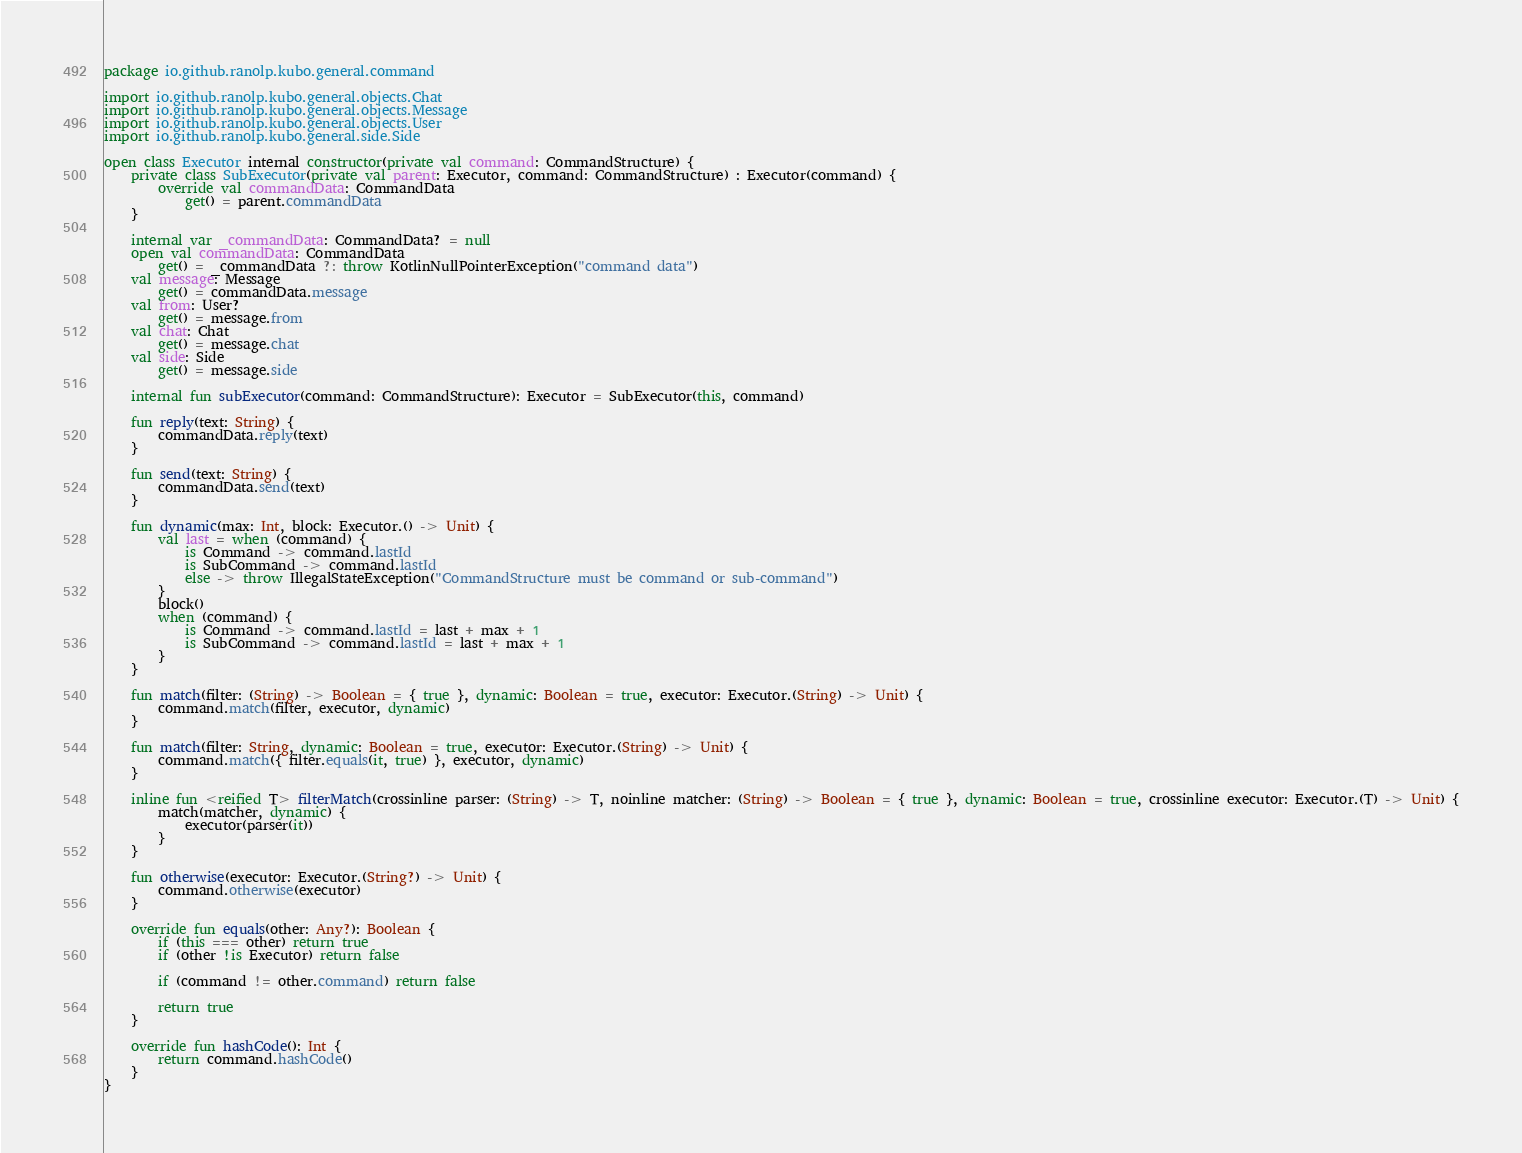Convert code to text. <code><loc_0><loc_0><loc_500><loc_500><_Kotlin_>package io.github.ranolp.kubo.general.command

import io.github.ranolp.kubo.general.objects.Chat
import io.github.ranolp.kubo.general.objects.Message
import io.github.ranolp.kubo.general.objects.User
import io.github.ranolp.kubo.general.side.Side

open class Executor internal constructor(private val command: CommandStructure) {
    private class SubExecutor(private val parent: Executor, command: CommandStructure) : Executor(command) {
        override val commandData: CommandData
            get() = parent.commandData
    }

    internal var _commandData: CommandData? = null
    open val commandData: CommandData
        get() = _commandData ?: throw KotlinNullPointerException("command data")
    val message: Message
        get() = commandData.message
    val from: User?
        get() = message.from
    val chat: Chat
        get() = message.chat
    val side: Side
        get() = message.side

    internal fun subExecutor(command: CommandStructure): Executor = SubExecutor(this, command)

    fun reply(text: String) {
        commandData.reply(text)
    }

    fun send(text: String) {
        commandData.send(text)
    }

    fun dynamic(max: Int, block: Executor.() -> Unit) {
        val last = when (command) {
            is Command -> command.lastId
            is SubCommand -> command.lastId
            else -> throw IllegalStateException("CommandStructure must be command or sub-command")
        }
        block()
        when (command) {
            is Command -> command.lastId = last + max + 1
            is SubCommand -> command.lastId = last + max + 1
        }
    }

    fun match(filter: (String) -> Boolean = { true }, dynamic: Boolean = true, executor: Executor.(String) -> Unit) {
        command.match(filter, executor, dynamic)
    }

    fun match(filter: String, dynamic: Boolean = true, executor: Executor.(String) -> Unit) {
        command.match({ filter.equals(it, true) }, executor, dynamic)
    }

    inline fun <reified T> filterMatch(crossinline parser: (String) -> T, noinline matcher: (String) -> Boolean = { true }, dynamic: Boolean = true, crossinline executor: Executor.(T) -> Unit) {
        match(matcher, dynamic) {
            executor(parser(it))
        }
    }

    fun otherwise(executor: Executor.(String?) -> Unit) {
        command.otherwise(executor)
    }

    override fun equals(other: Any?): Boolean {
        if (this === other) return true
        if (other !is Executor) return false

        if (command != other.command) return false

        return true
    }

    override fun hashCode(): Int {
        return command.hashCode()
    }
}</code> 